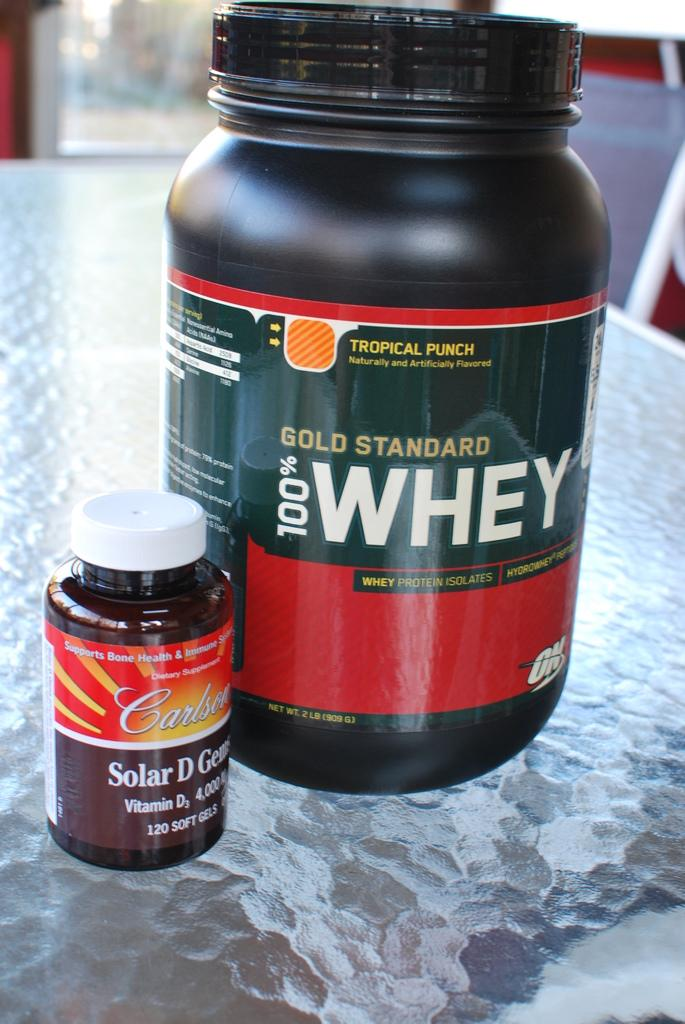<image>
Summarize the visual content of the image. A large bottle of Gold Standard 100% Whey sits next to a smaller bottle of vitamin D. 